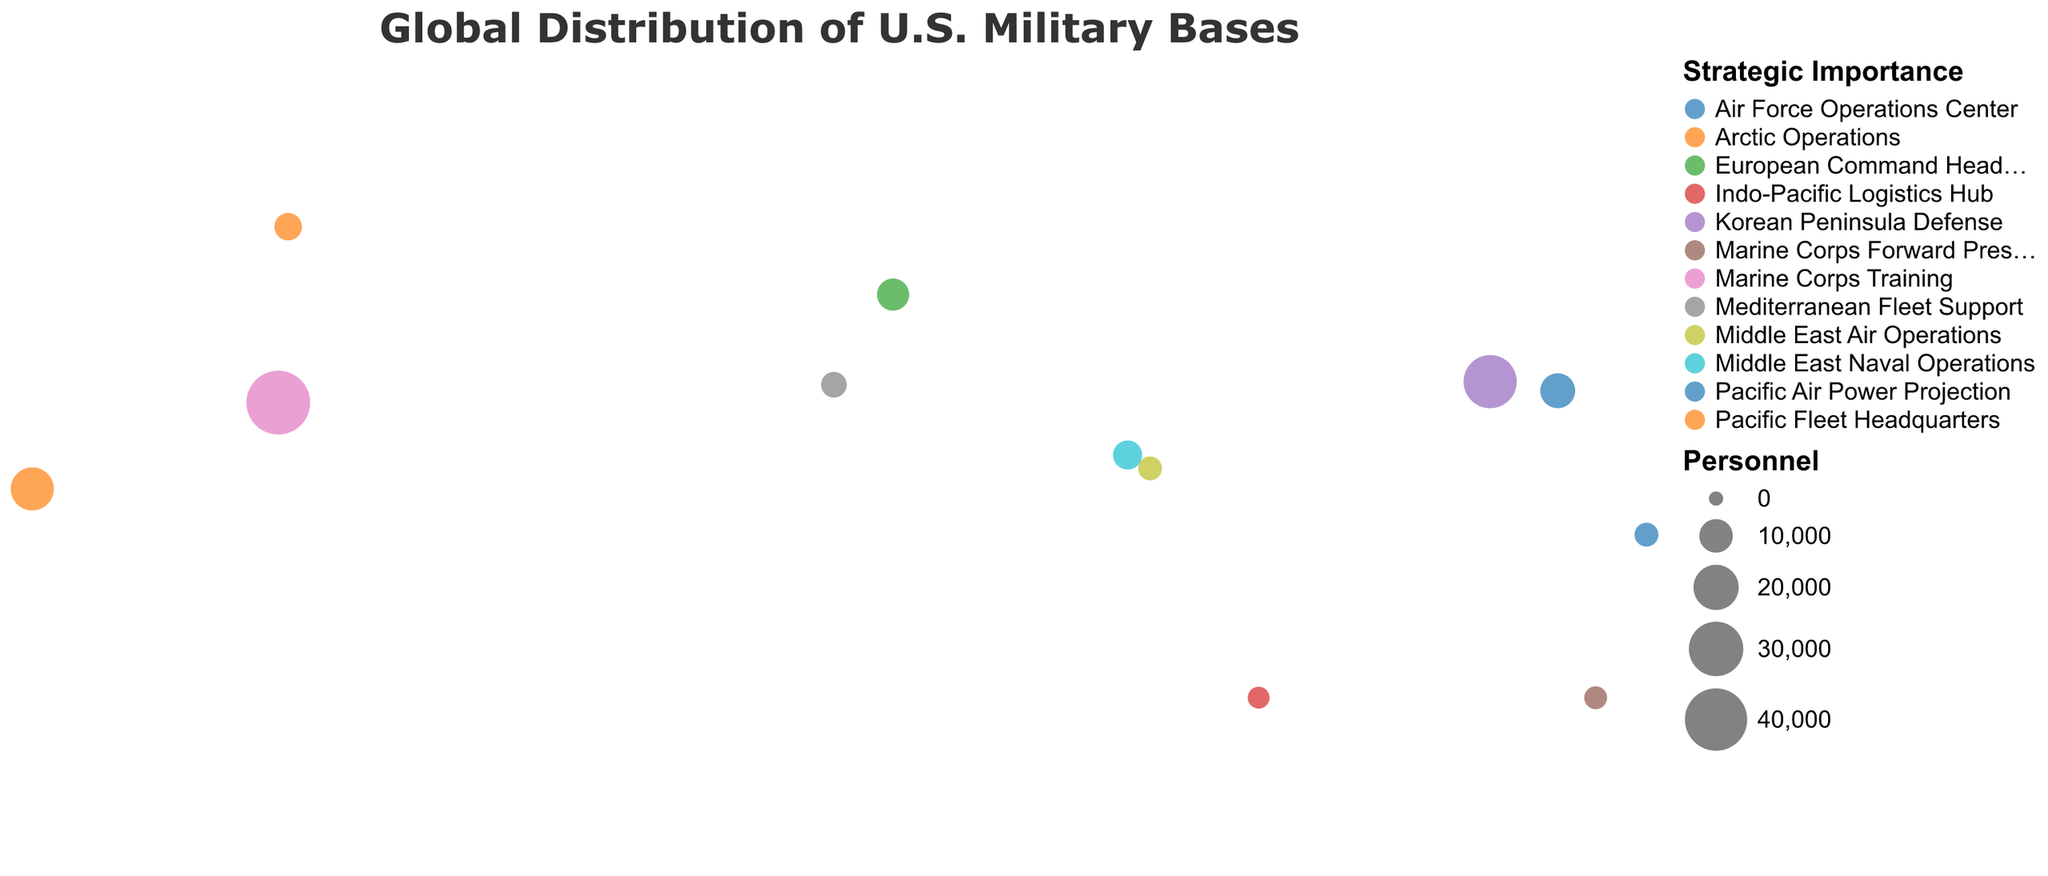How many total U.S. military bases are shown on the map? To count the total number of bases, enumerate each unique data point representing a base on the map. There are 12 bases listed in the dataset.
Answer: 12 Which base has the largest number of personnel? By comparing the size of the circles corresponding to personnel numbers, Camp Pendleton has the largest circle on the map, indicating the highest personnel count. It has 42,000 personnel.
Answer: Camp Pendleton What is the strategic importance of the base located in Bahrain? Look at the tooltip or the legend for the base in Bahrain. The strategic importance is "Middle East Naval Operations".
Answer: Middle East Naval Operations Which country hosts the highest number of U.S. military bases? Check the locations and group them by country. The United States hosts the most bases, with three bases (Camp Pendleton, Joint Base Pearl Harbor-Hickam, Fort Wainwright).
Answer: United States What is the total number of personnel stationed across all bases in Japan? Sum the personnel counts for all bases in Japan (Yokota Air Base: 11,000 + Camp Schwab: 3,500). The total is 14,500.
Answer: 14,500 Which bases are involved in Middle East operations, and how many personnel are at each? Identify bases with strategic importance relating to Middle East operations. Naval Support Activity Bahrain and Al Dhafra Air Base are the two bases. Personnel count is Bahrain: 7,000 and UAE: 4,000.
Answer: Bahrain: 7,000, UAE: 4,000 Rank the bases in the Pacific region by personnel size. Examine the personnel sizes for Andersen Air Force Base (Guam: 4,000), Joint Base Pearl Harbor-Hickam (United States: 18,000), Camp Schwab (Japan: 3,500). Rank by 18,000, 4,000, then 3,500.
Answer: Joint Base Pearl Harbor-Hickam, Andersen Air Force Base, Camp Schwab Which base in Asia has the second highest number of personnel? Compare personnel sizes for all bases in Asia (Camp Humphreys: 28,500, Yokota Air Base: 11,000, Camp Schwab: 3,500, Al Dhafra Air Base: 4,000). The second highest is Yokota Air Base with 11,000 personnel.
Answer: Yokota Air Base What strategic roles do the bases in Europe have? Identify the strategic importance of bases in Europe. Ramstein Air Base (Germany) serves as European Command Headquarters, Naval Station Rota (Spain) serves as Mediterranean Fleet Support.
Answer: European Command Headquarters, Mediterranean Fleet Support Are there any regions on the map without any U.S. military bases? Check the geographic plot to visually confirm regions without circles representing bases. No bases are depicted in Africa, South America, or Antarctica.
Answer: Africa, South America, Antarctica 